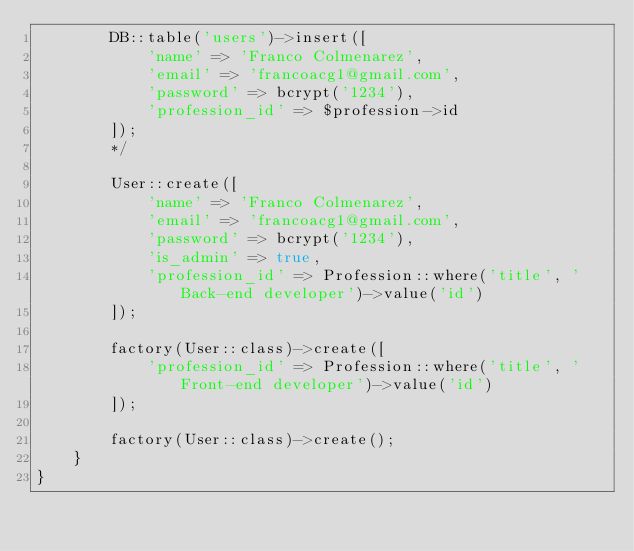Convert code to text. <code><loc_0><loc_0><loc_500><loc_500><_PHP_>        DB::table('users')->insert([
            'name' => 'Franco Colmenarez',
            'email' => 'francoacg1@gmail.com',
            'password' => bcrypt('1234'),
            'profession_id' => $profession->id
        ]);
        */

        User::create([
            'name' => 'Franco Colmenarez',
            'email' => 'francoacg1@gmail.com',
            'password' => bcrypt('1234'),
            'is_admin' => true,
            'profession_id' => Profession::where('title', 'Back-end developer')->value('id')
        ]);

        factory(User::class)->create([
            'profession_id' => Profession::where('title', 'Front-end developer')->value('id')
        ]);

        factory(User::class)->create();
    }
}
</code> 